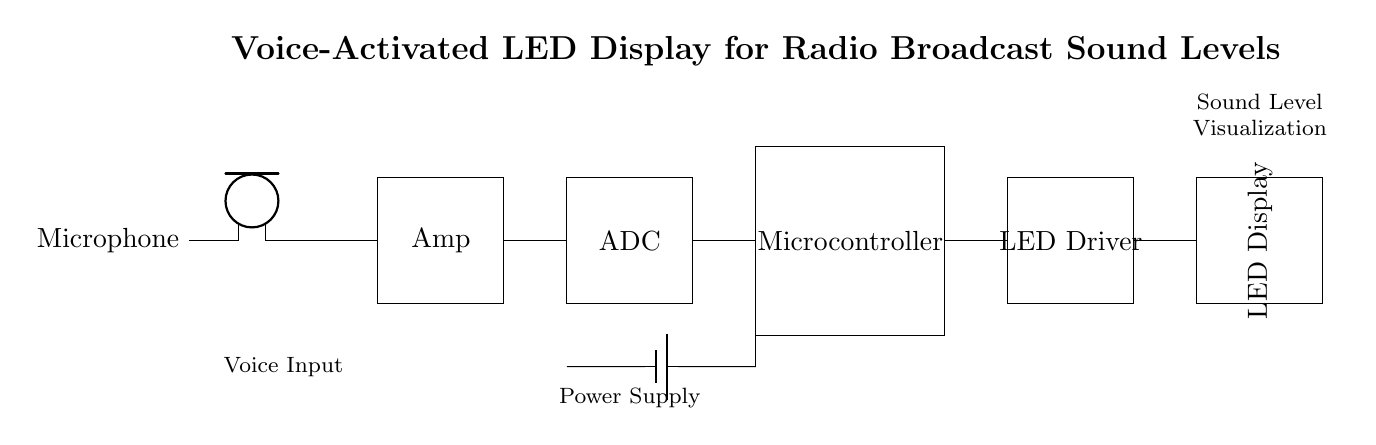What component receives sound input? The microphone is the component that receives sound input from the environment. It is the first element in the circuit diagram and is labeled as such.
Answer: Microphone What does the ADC stand for? ADC stands for Analog to Digital Converter, which is indicated in the rectangle labeled as ADC in the circuit diagram. This component converts analog signals from the amplifier into digital signals for the microcontroller.
Answer: Analog to Digital Converter How many main components are in the circuit? There are five main components shown in the circuit: Microphone, Amplifier, ADC, Microcontroller, and LED Driver. Counting them provides the total number of main components present.
Answer: Five What is the purpose of the LED Driver? The LED Driver is used to control the LED Display based on the signals processed by the microcontroller. It is specifically marked in the circuit and crucial for illuminating the display based on sound levels.
Answer: Control LED Display Which component processes the audio after digitization? The microcontroller processes the audio after digitization. It follows the ADC in the circuit, meaning it takes the digital signals from the ADC for further processing and decision-making.
Answer: Microcontroller What is being visualized in the LED Display? The LED Display visualizes sound levels, as specified in the title of the circuit diagram. This means that the LED display indicates the amplitude or intensity of the audio input in a visual format during radio broadcasts.
Answer: Sound levels What provides power to the circuit? The power supply is provided by the battery, which is clearly labeled in the circuit diagram. The battery connects to the ADC and microcontroller, supplying the necessary voltage for operation.
Answer: Battery 